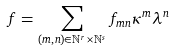Convert formula to latex. <formula><loc_0><loc_0><loc_500><loc_500>f = \sum _ { ( m , n ) \in \mathbb { N } ^ { r } \times \mathbb { N } ^ { s } } f _ { m n } \kappa ^ { m } \lambda ^ { n }</formula> 